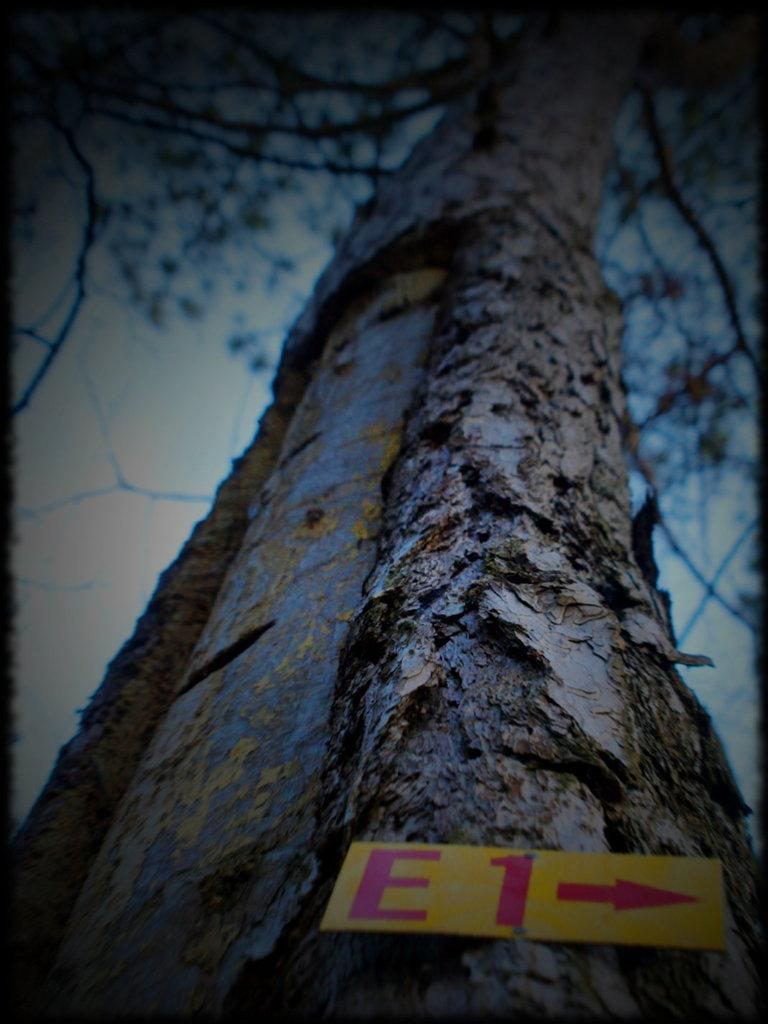What is the main subject of the image? The main subject of the image is a tree stem. What is located at the bottom of the image? There is a yellow color board with text at the bottom of the image. What can be seen in the background of the image? There is a tree and the sky visible in the background of the image. What type of silver object is balanced on the tree stem in the image? There is no silver object present in the image, and therefore no such object can be balanced on the tree stem. 